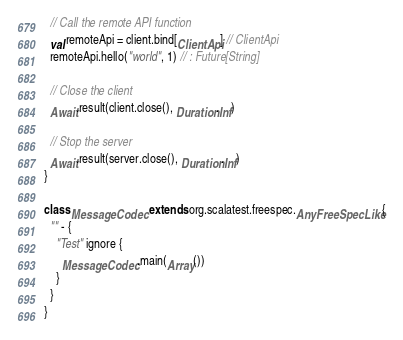<code> <loc_0><loc_0><loc_500><loc_500><_Scala_>
  // Call the remote API function
  val remoteApi = client.bind[ClientApi] // ClientApi
  remoteApi.hello("world", 1) // : Future[String]

  // Close the client
  Await.result(client.close(), Duration.Inf)

  // Stop the server
  Await.result(server.close(), Duration.Inf)
}

class MessageCodec extends org.scalatest.freespec.AnyFreeSpecLike {
  "" - {
    "Test" ignore {
      MessageCodec.main(Array())
    }
  }
}
</code> 